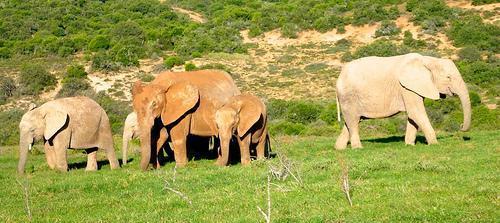How many of the elephant's faces are visible?
Give a very brief answer. 5. 